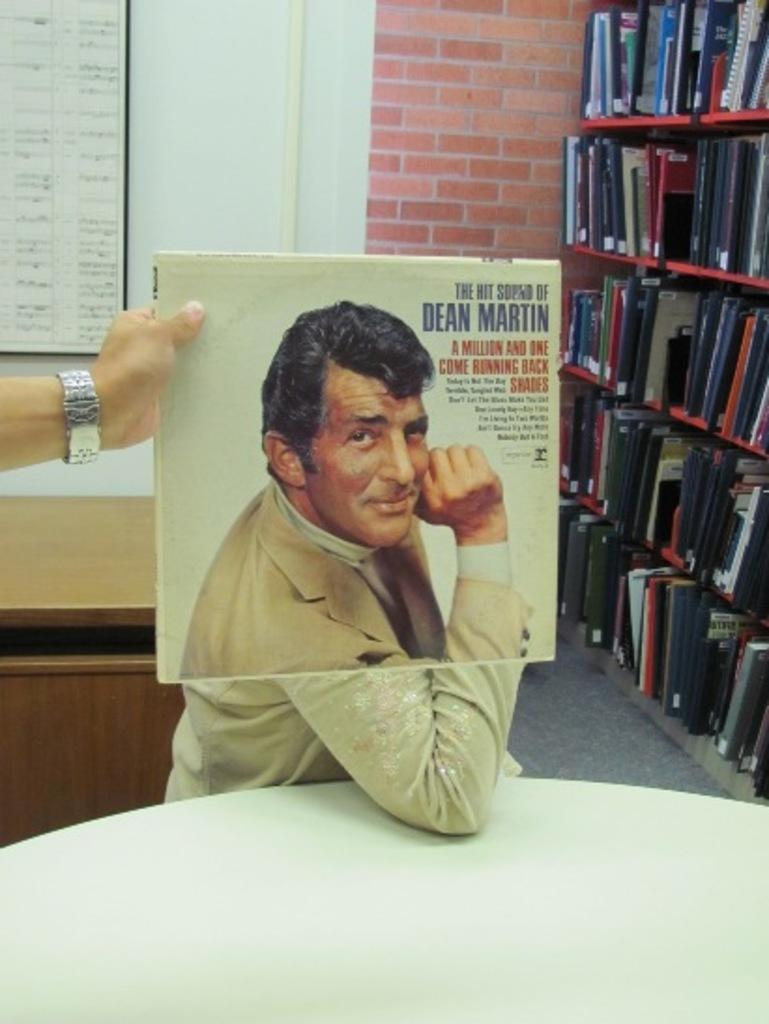<image>
Give a short and clear explanation of the subsequent image. A man olding an album of Dean Martin in front of another person. 